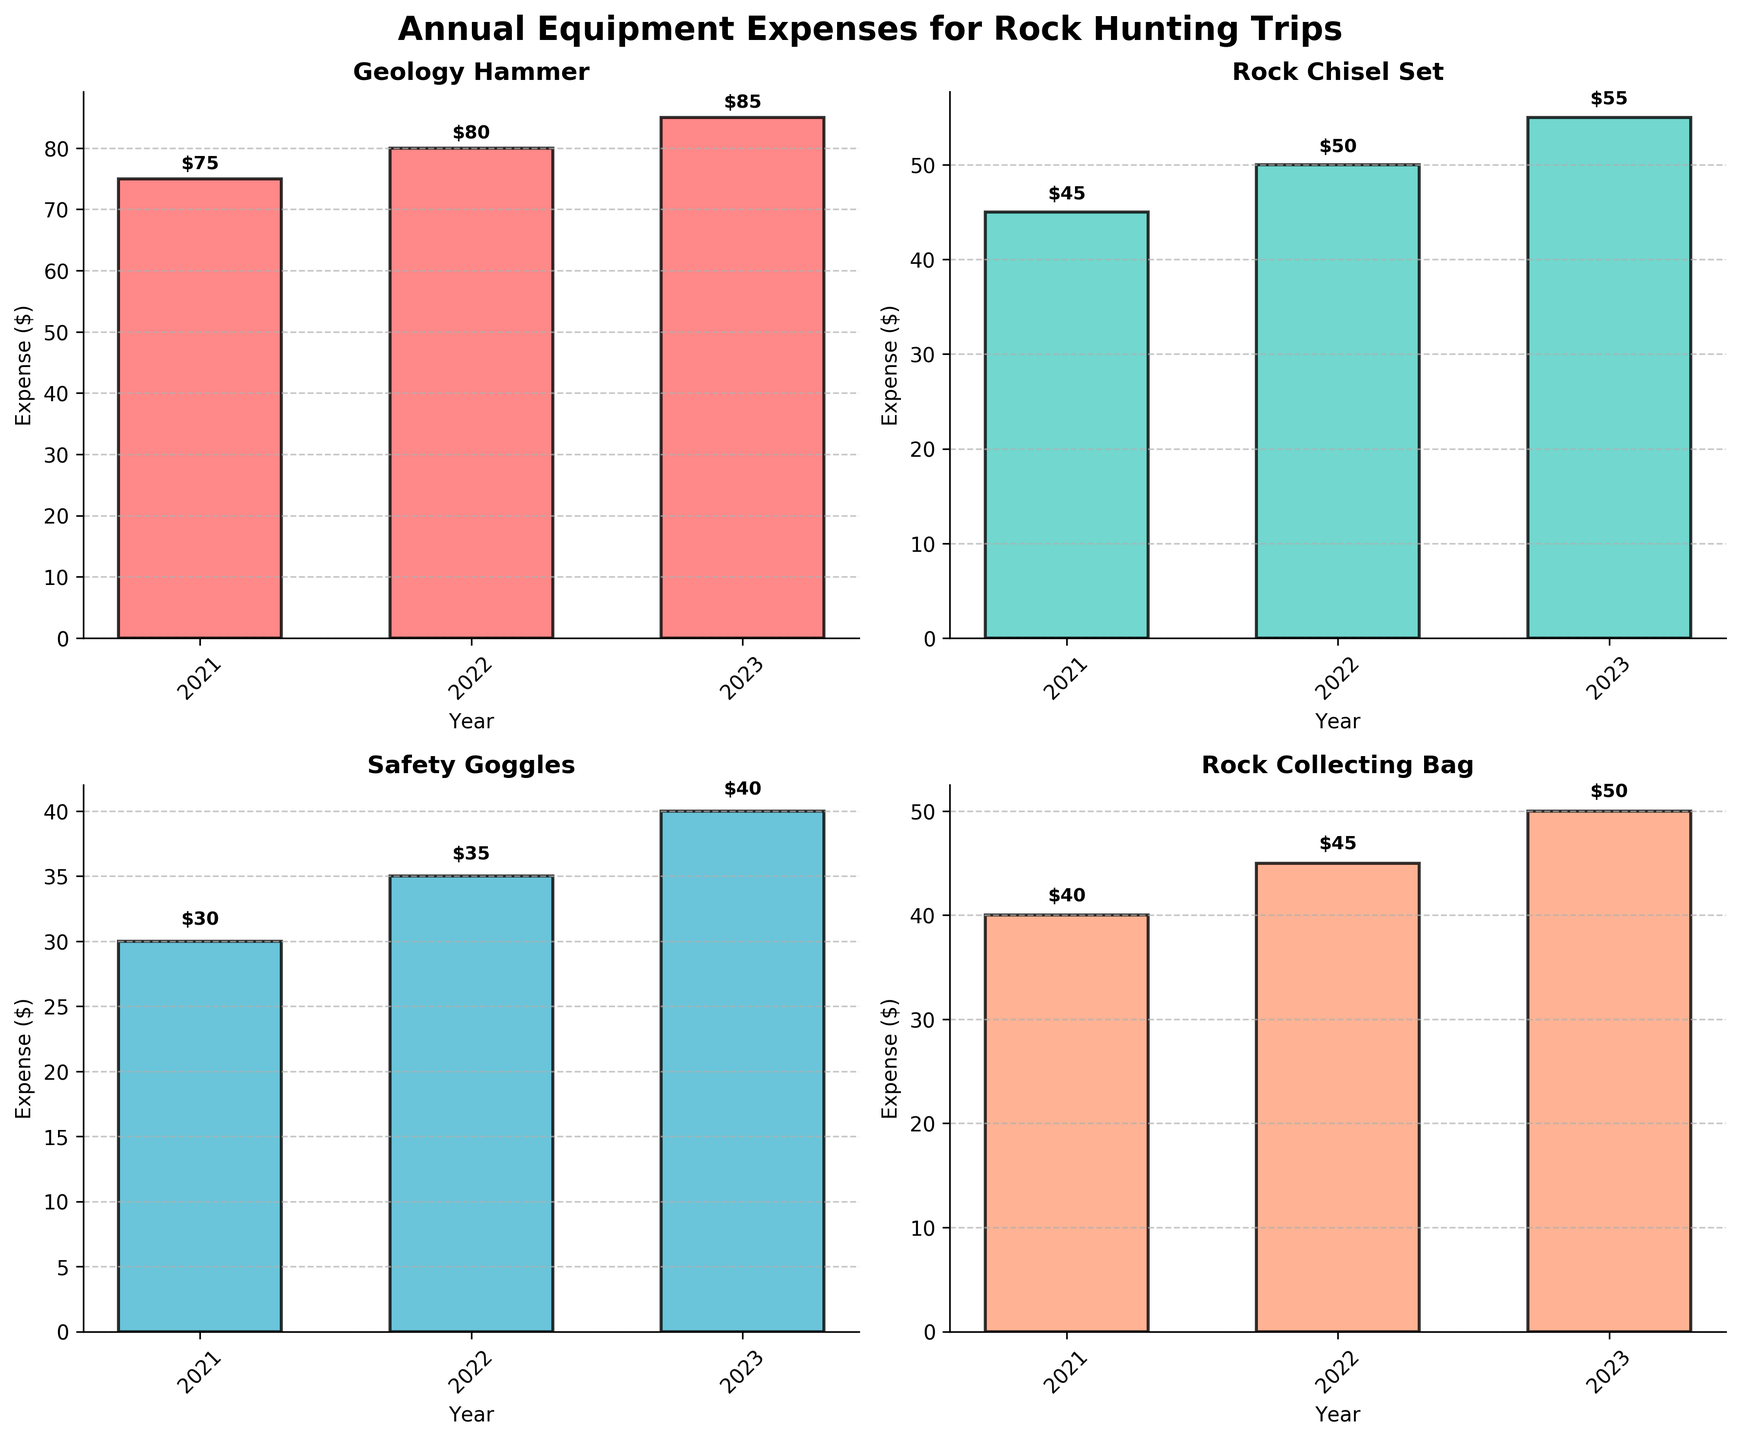What is the title of the figure? The title of the figure is written at the top and provides an overview of the content being displayed.
Answer: Annual Equipment Expenses for Rock Hunting Trips What colors are used for the bar charts? The colors of the bars can be seen in the different subplots, there are four distinct colors.
Answer: Red, turquoise, light blue, and light salmon What is the expense for a Geology Hammer in 2021? Locate the subplot titled "Geology Hammer" and check the height of the bar corresponding to the year 2021.
Answer: $75 Which tool had the highest expense in 2023? Compare the heights of the bars for the year 2023 in all subplots to identify the tallest one.
Answer: Geology Hammer What is the total expense for Safety Goggles from 2021 to 2023? Sum the expenses shown in the Safety Goggles subplot for the years 2021, 2022, and 2023.
Answer: $105 Which year had the lowest total expense across all tools? Add up the expenses for each tool for each year, then compare the totals to identify the lowest one.
Answer: 2021 By how much did the expense for Rock Chisel Set increase from 2021 to 2023? Subtract the expense in 2021 from the expense in 2023 for the Rock Chisel Set subplot.
Answer: $10 What is the average annual expense for the Rock Collecting Bag from 2021 to 2023? Sum the expenses for the Rock Collecting Bag for 2021, 2022, and 2023, then divide by 3.
Answer: $45 Which tool type had the most consistent annual expenses from 2021 to 2023? Examine the bars across all years for each tool type and identify which has the least variation in height.
Answer: Rock Collecting Bag What is the difference in expenses for Safety Goggles between 2022 and 2023? Subtract the expense of Safety Goggles in 2022 from the expense in 2023.
Answer: $5 